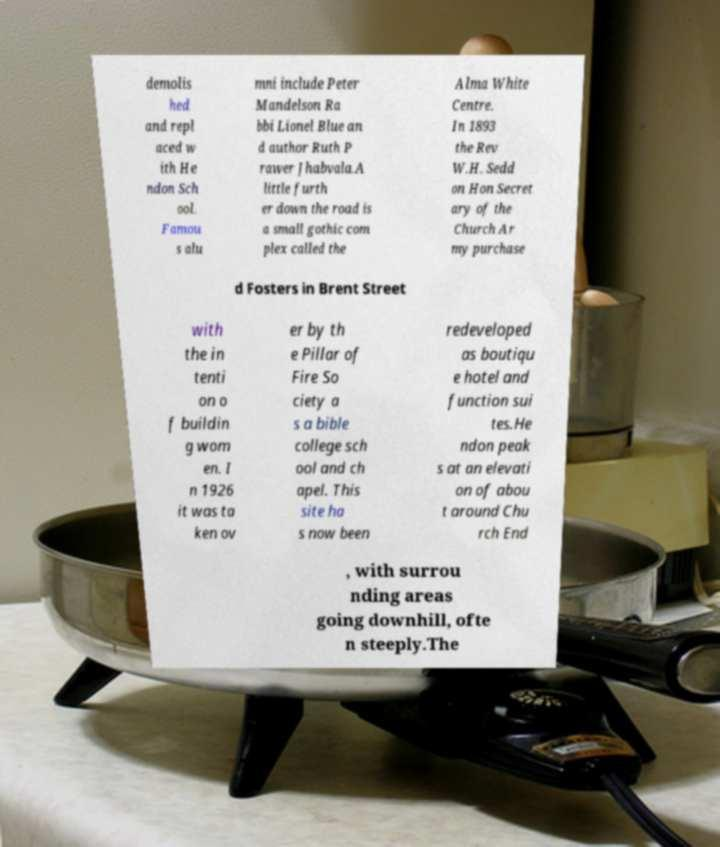Please read and relay the text visible in this image. What does it say? demolis hed and repl aced w ith He ndon Sch ool. Famou s alu mni include Peter Mandelson Ra bbi Lionel Blue an d author Ruth P rawer Jhabvala.A little furth er down the road is a small gothic com plex called the Alma White Centre. In 1893 the Rev W.H. Sedd on Hon Secret ary of the Church Ar my purchase d Fosters in Brent Street with the in tenti on o f buildin g wom en. I n 1926 it was ta ken ov er by th e Pillar of Fire So ciety a s a bible college sch ool and ch apel. This site ha s now been redeveloped as boutiqu e hotel and function sui tes.He ndon peak s at an elevati on of abou t around Chu rch End , with surrou nding areas going downhill, ofte n steeply.The 